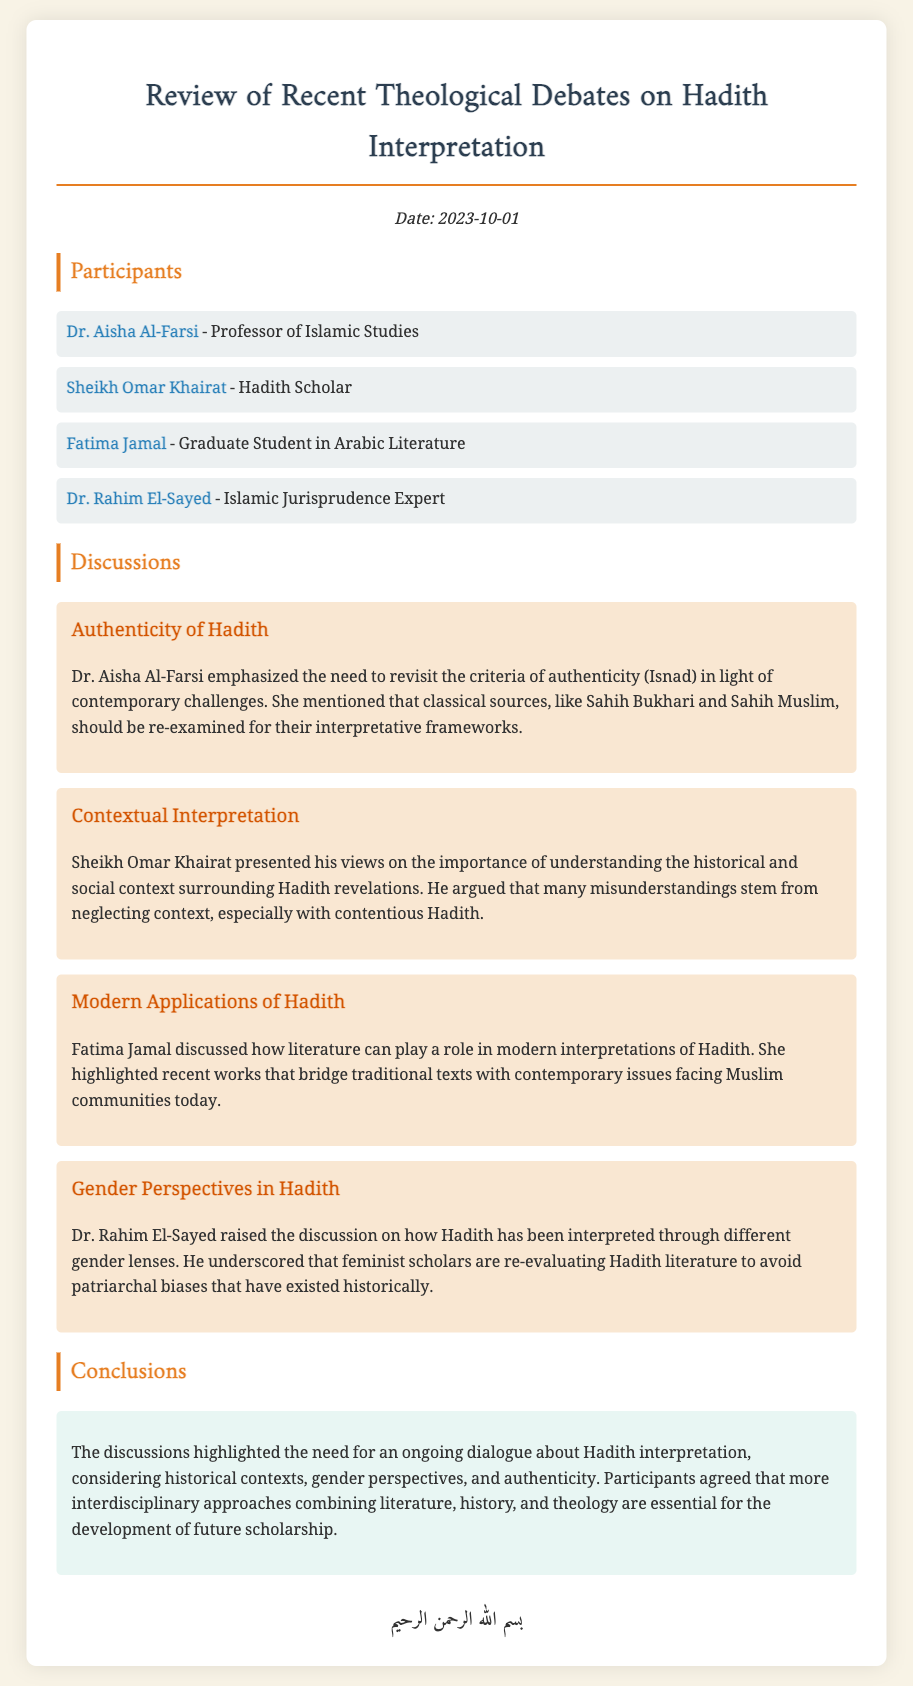What is the date of the meeting? The date of the meeting is mentioned at the top of the document.
Answer: 2023-10-01 Who emphasized the need to revisit the criteria of authenticity? This question looks for a specific participant's name mentioned in the discussions about authenticity.
Answer: Dr. Aisha Al-Farsi What topic did Sheikh Omar Khairat discuss? The document outlines various topics discussed and matches them with corresponding participants.
Answer: Contextual Interpretation Which scholar focuses on gender perspectives in Hadith? This requires recalling a participant's name associated with a specific discussion on gender perspectives.
Answer: Dr. Rahim El-Sayed What type of approaches do participants agree are essential for future scholarship? The document concludes with a summary that highlights the need for certain approaches in Hadith interpretation.
Answer: Interdisciplinary approaches What role does Fatima Jamal believe literature plays in Hadith interpretation? This question asks about the perspective of one of the participants on literature's importance in the discussions.
Answer: Modern interpretations of Hadith What is a key aspect highlighted by the participants regarding Hadith interpretation? This seeks to summarize an important point made collectively during the discussions.
Answer: Ongoing dialogue Who is a graduate student in Arabic Literature? This question requires identifying one of the participants by their academic status and field of study.
Answer: Fatima Jamal 